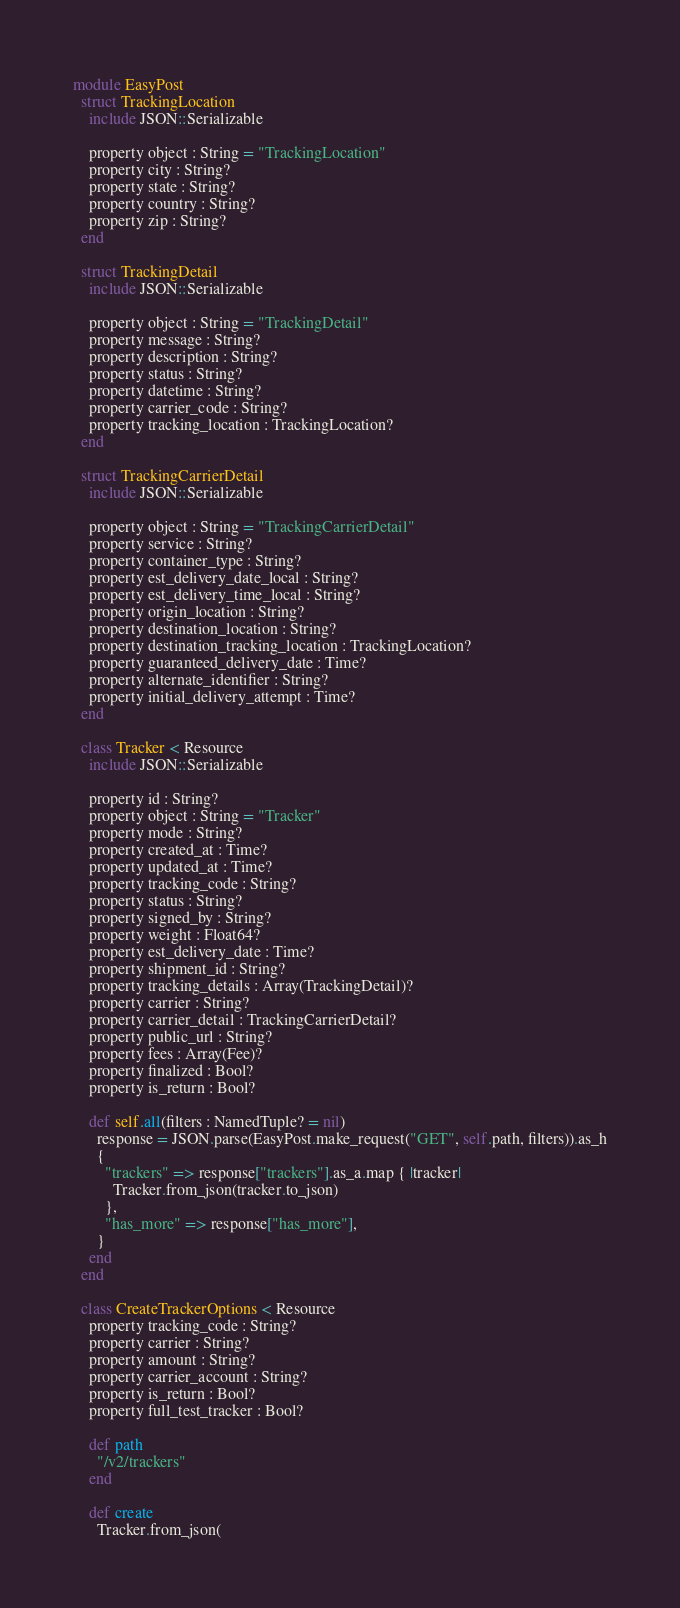Convert code to text. <code><loc_0><loc_0><loc_500><loc_500><_Crystal_>module EasyPost
  struct TrackingLocation
    include JSON::Serializable

    property object : String = "TrackingLocation"
    property city : String?
    property state : String?
    property country : String?
    property zip : String?
  end

  struct TrackingDetail
    include JSON::Serializable

    property object : String = "TrackingDetail"
    property message : String?
    property description : String?
    property status : String?
    property datetime : String?
    property carrier_code : String?
    property tracking_location : TrackingLocation?
  end

  struct TrackingCarrierDetail
    include JSON::Serializable

    property object : String = "TrackingCarrierDetail"
    property service : String?
    property container_type : String?
    property est_delivery_date_local : String?
    property est_delivery_time_local : String?
    property origin_location : String?
    property destination_location : String?
    property destination_tracking_location : TrackingLocation?
    property guaranteed_delivery_date : Time?
    property alternate_identifier : String?
    property initial_delivery_attempt : Time?
  end

  class Tracker < Resource
    include JSON::Serializable

    property id : String?
    property object : String = "Tracker"
    property mode : String?
    property created_at : Time?
    property updated_at : Time?
    property tracking_code : String?
    property status : String?
    property signed_by : String?
    property weight : Float64?
    property est_delivery_date : Time?
    property shipment_id : String?
    property tracking_details : Array(TrackingDetail)?
    property carrier : String?
    property carrier_detail : TrackingCarrierDetail?
    property public_url : String?
    property fees : Array(Fee)?
    property finalized : Bool?
    property is_return : Bool?

    def self.all(filters : NamedTuple? = nil)
      response = JSON.parse(EasyPost.make_request("GET", self.path, filters)).as_h
      {
        "trackers" => response["trackers"].as_a.map { |tracker|
          Tracker.from_json(tracker.to_json)
        },
        "has_more" => response["has_more"],
      }
    end
  end

  class CreateTrackerOptions < Resource
    property tracking_code : String?
    property carrier : String?
    property amount : String?
    property carrier_account : String?
    property is_return : Bool?
    property full_test_tracker : Bool?

    def path
      "/v2/trackers"
    end

    def create
      Tracker.from_json(</code> 